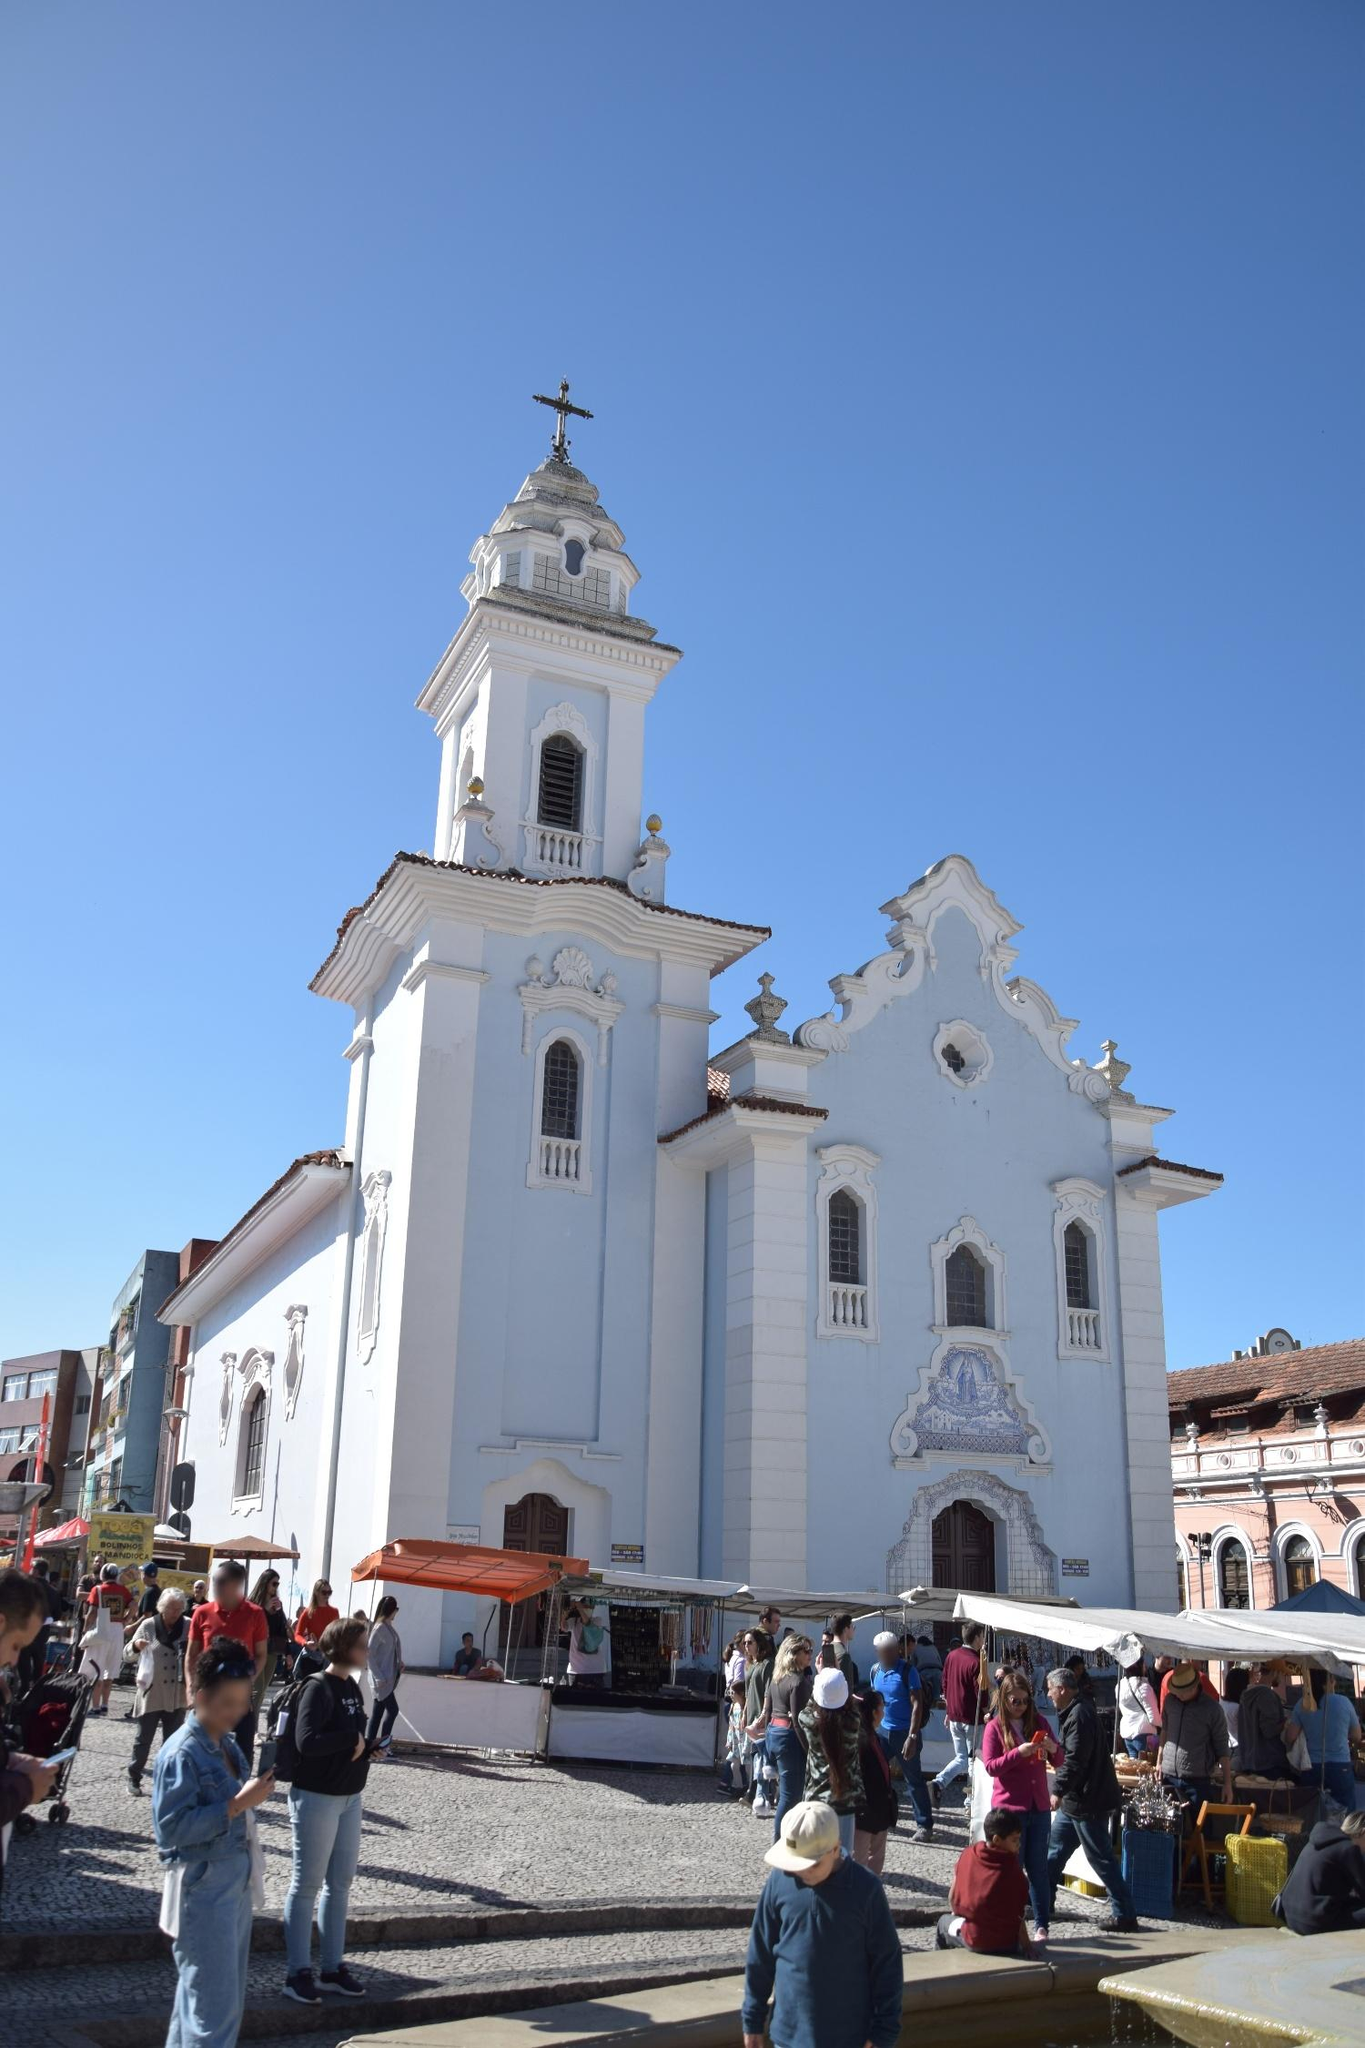What do you think is the significance of having vendors and people bustling around this church? The presence of vendors and people bustling around the Igreja de Nossa Senhora do Rosário dos Pretos underscores the church’s role as a community focal point. This activity highlights the intersection of daily life and spiritual practice, the vendors offering local goods demonstrate the economic vibrancy and cultural richness of the area. The church, standing as a historical and spiritual monument, draws people not only for worship but as a central meeting place where social, economic, and religious lives intertwine. Could you describe a typical day in this place? A typical day around the Igreja de Nossa Senhora do Rosário dos Pretos begins with the first light bathing the church's white facade in a soft glow. Early in the morning, vendors start setting up their stalls, bringing a variety of colorful goods including fresh produce, handcrafted items, and souvenirs. As the day progresses, tourists and locals alike flock to the area, admiring the church's architectural beauty or attending morning mass. The air fills with the sounds of chatter, the ringing of the church bell, and the lively calls of vendors. By afternoon, the square is bustling with activity; children play near the fountain, families shop at the stalls, and couples enjoy leisurely walks. Even as the evening sets in and the vendors begin packing up, a sense of community remains, with people gathering in small groups, sharing stories and laughter, against the serene backdrop of the illuminated church. Imagine if the church could talk! What stories do you think it would tell? If the Igreja de Nossa Senhora do Rosário dos Pretos could talk, it would recount tales from centuries past. It would whisper stories of its construction in the 18th century by African slaves and freedmen who sought a place to worship amidst a society that marginalized them. It would speak of resilience and faith, of countless weddings, baptisms, and funerals that it has witnessed. The church might share memories of the vibrant festas (festivals), the music and dance ceremonies where the streets overflow with joy and tradition during annual celebrations. It would remember the changes it has seen, from the cobblestone streets filled with horse-drawn carriages to modern-day vehicles bustling by. The church would tell of the quiet prayers said in its pews, of the solace it provided during difficult times, and of the hope it has always symbolized to the people of Salvador. 